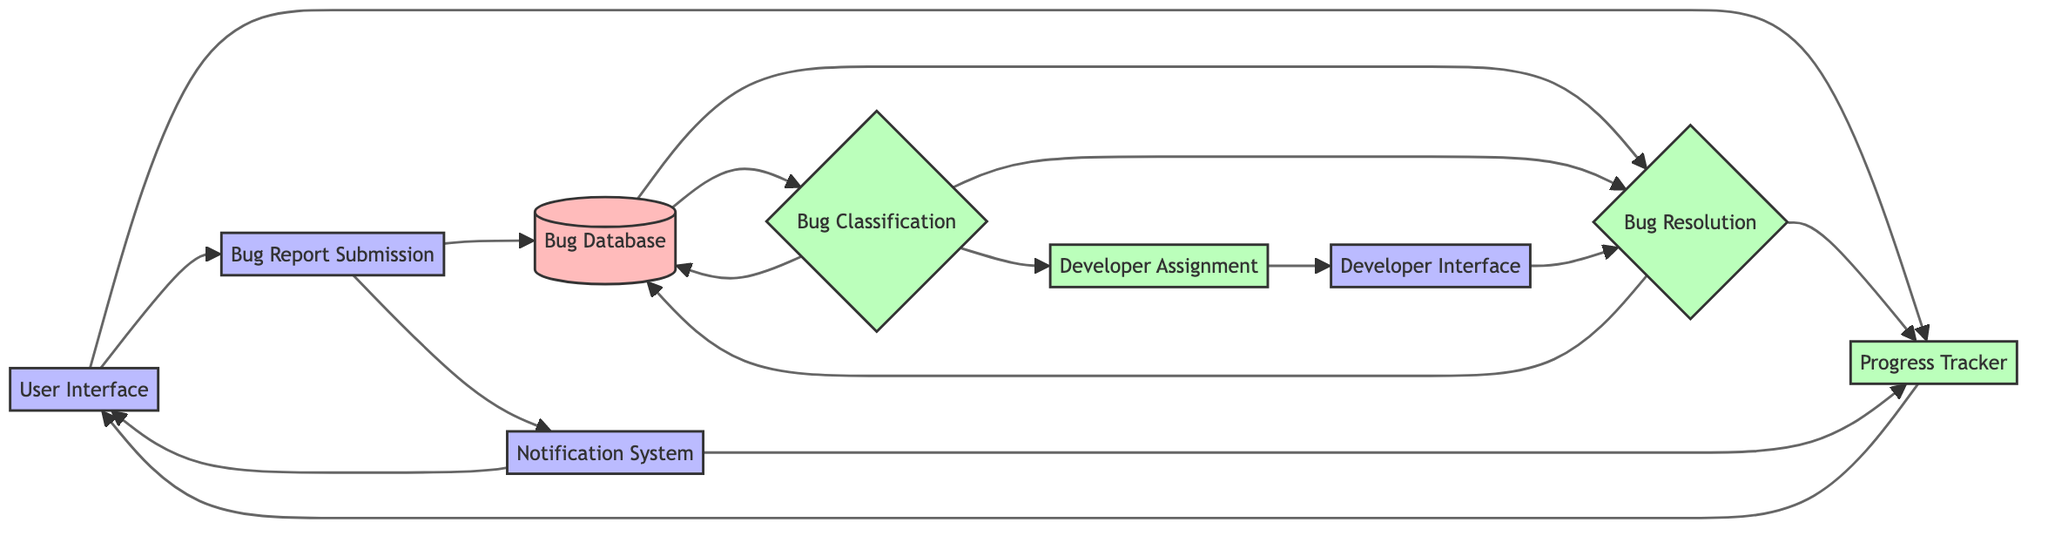What is the purpose of the Bug Report Submission element? The Bug Report Submission element serves as an interface for users to submit bug reports, allowing them to communicate issues directly to the system.
Answer: Interface for users to submit bug reports How many main processes are present in the diagram? There are four main processes in the diagram: Bug Classification, Developer Assignment, Bug Resolution, and Progress Tracker. By counting each of these processes, we find a total of four.
Answer: Four Which element connects directly to both the Bug Database and the Progress Tracker? The Bug Resolution element connects directly to both the Bug Database and the Progress Tracker. It shows the flow of information required for bug resolution and tracking progress.
Answer: Bug Resolution What type of element is the Notification System? The Notification System is categorized as an interface element. It is designed to interact with users by notifying them about the status of their bug reports.
Answer: Interface Which element follows Developer Assignment in the workflow? The Developer Interface follows Developer Assignment in the workflow. This indicates that after bugs are assigned to developers, they access the Developer Interface to work on those bugs.
Answer: Developer Interface What does the Progress Tracker do? The Progress Tracker is responsible for tracking the resolution progress of each bug, ensuring that both users and developers can monitor the status of bug fixes effectively.
Answer: Tracking the resolution progress of each bug Which two components are connected to the Bug Database directly? The Bug Classification and Bug Resolution components are connected directly to the Bug Database. This indicates that both processes rely on the information stored within the Bug Database to function effectively.
Answer: Bug Classification and Bug Resolution How does the User Interface integrate with the Notification System? The User Interface integrates with the Notification System by allowing users to receive updates on their bug reports. The connection indicates that the User Interface can serve notifications back to users.
Answer: By notifying users about report status What happens after a bug is classified? After a bug is classified, it can either be assigned to a developer for resolution or further categorized for tracking, both of which are subsequent steps following bug classification.
Answer: It can be assigned or resolved What is the relationship between the Bug Resolution and Progress Tracker? The relationship between Bug Resolution and Progress Tracker is that the Progress Tracker relies on the Bug Resolution process to update and display the status of each bug that is being resolved.
Answer: The Progress Tracker updates after Bug Resolution 